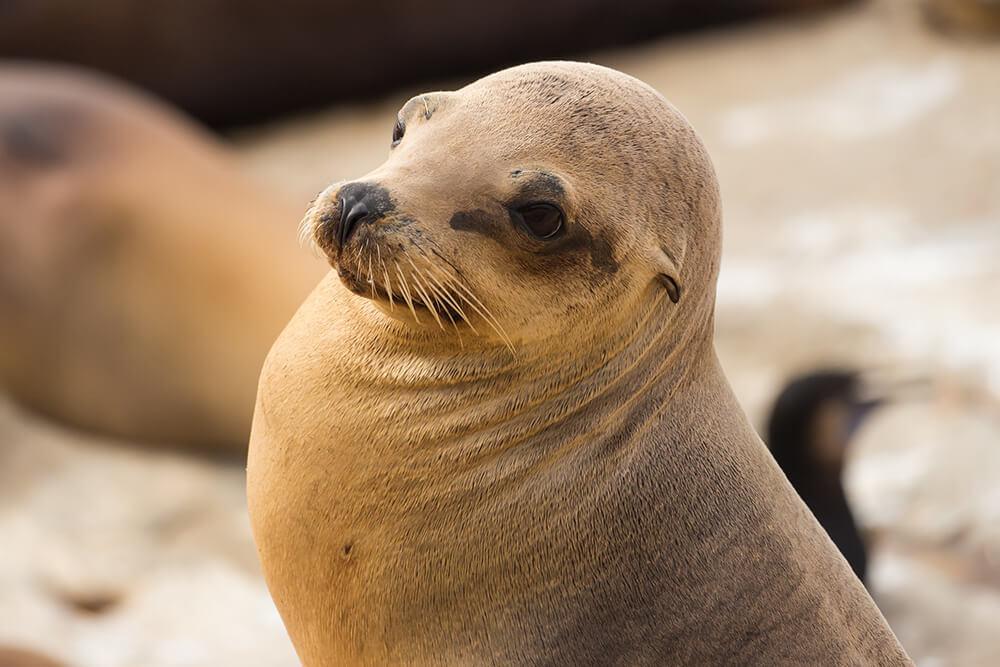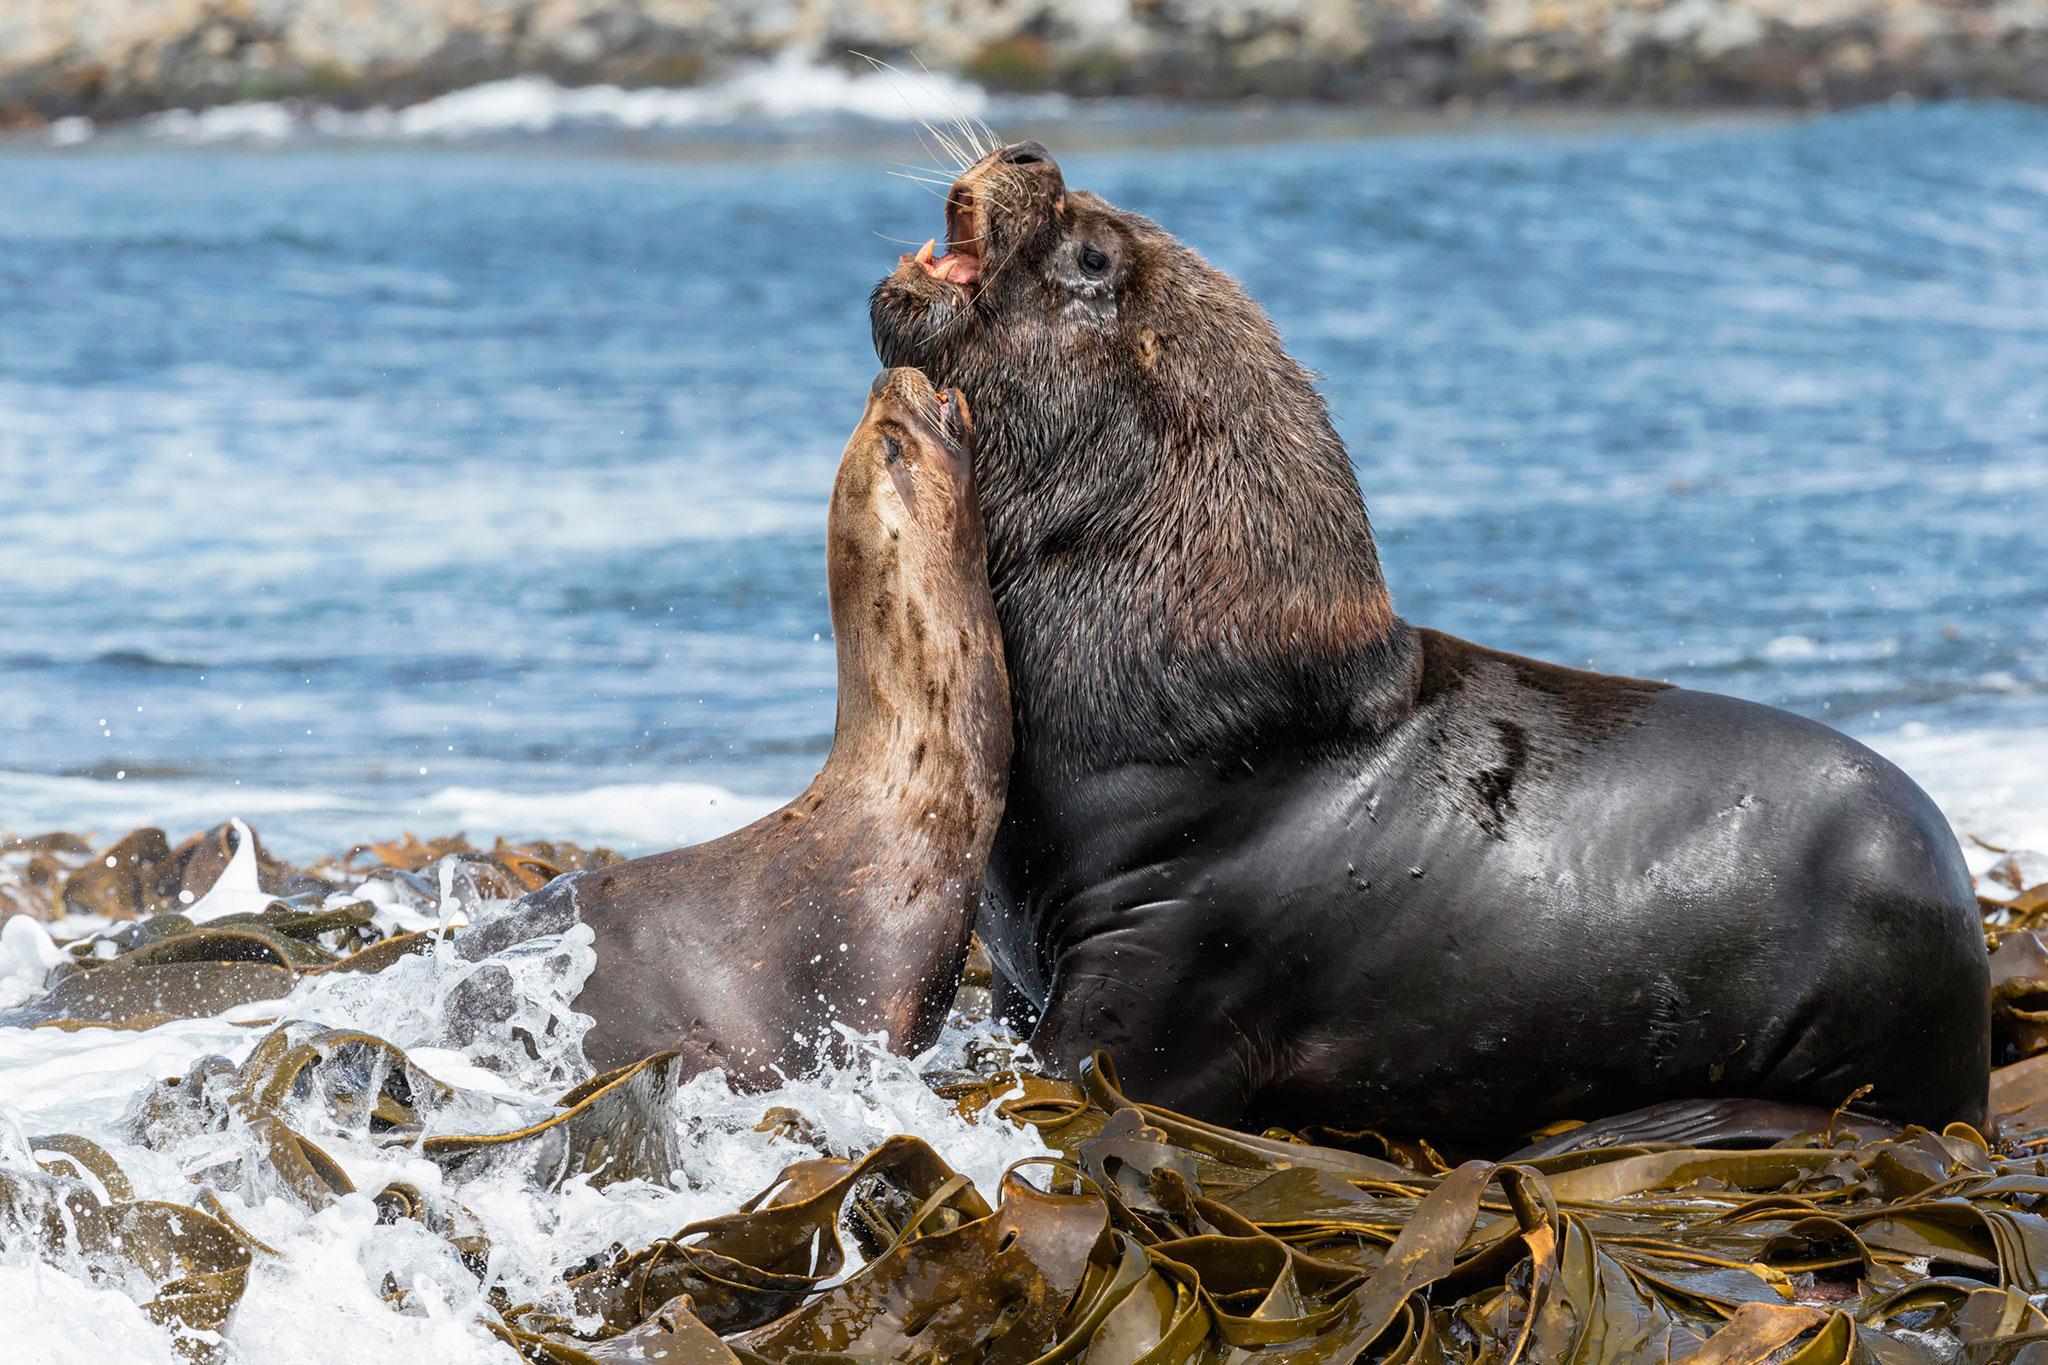The first image is the image on the left, the second image is the image on the right. Given the left and right images, does the statement "In one image, there is a seal that appears to be looking directly at the camera." hold true? Answer yes or no. No. The first image is the image on the left, the second image is the image on the right. Evaluate the accuracy of this statement regarding the images: "In  at least one image, there is a single brown sea lion facing left on the sandy beach with the ocean behind them.". Is it true? Answer yes or no. No. 